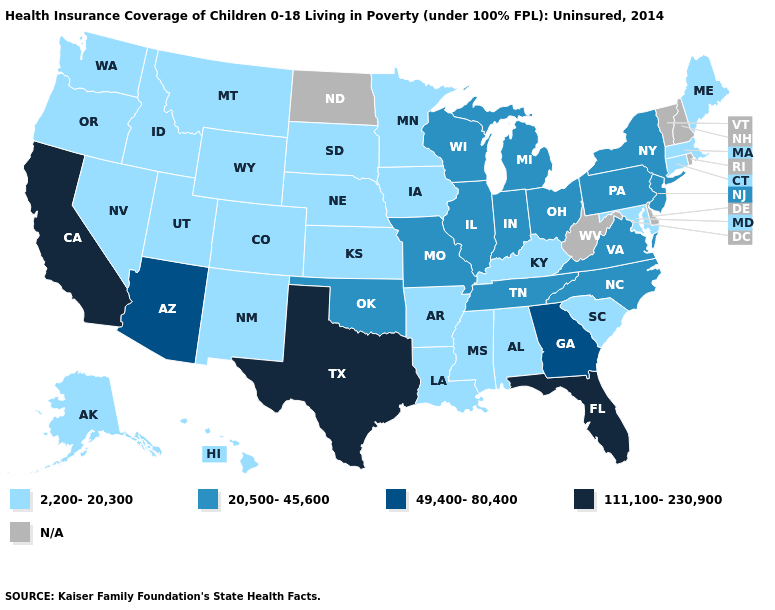What is the highest value in states that border Iowa?
Answer briefly. 20,500-45,600. What is the lowest value in the USA?
Keep it brief. 2,200-20,300. What is the value of Louisiana?
Write a very short answer. 2,200-20,300. Which states have the highest value in the USA?
Give a very brief answer. California, Florida, Texas. What is the value of Massachusetts?
Give a very brief answer. 2,200-20,300. Does North Carolina have the highest value in the USA?
Be succinct. No. Name the states that have a value in the range N/A?
Give a very brief answer. Delaware, New Hampshire, North Dakota, Rhode Island, Vermont, West Virginia. What is the lowest value in states that border Mississippi?
Write a very short answer. 2,200-20,300. Does Texas have the highest value in the USA?
Short answer required. Yes. Does Connecticut have the highest value in the Northeast?
Be succinct. No. How many symbols are there in the legend?
Answer briefly. 5. What is the highest value in the MidWest ?
Keep it brief. 20,500-45,600. Name the states that have a value in the range 111,100-230,900?
Write a very short answer. California, Florida, Texas. 